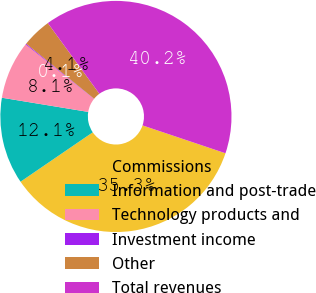Convert chart. <chart><loc_0><loc_0><loc_500><loc_500><pie_chart><fcel>Commissions<fcel>Information and post-trade<fcel>Technology products and<fcel>Investment income<fcel>Other<fcel>Total revenues<nl><fcel>35.3%<fcel>12.14%<fcel>8.13%<fcel>0.12%<fcel>4.13%<fcel>40.19%<nl></chart> 